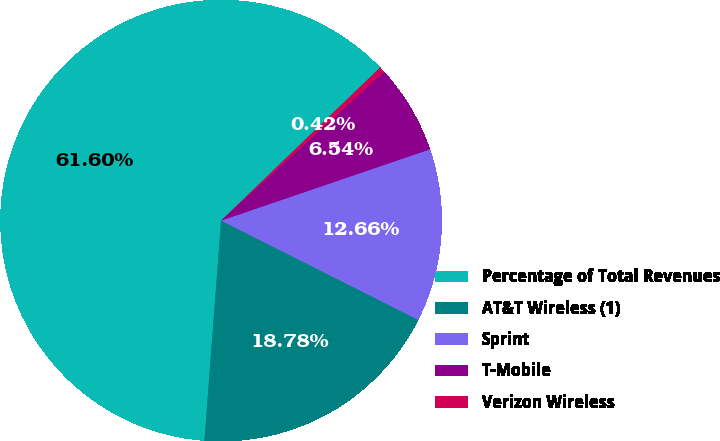<chart> <loc_0><loc_0><loc_500><loc_500><pie_chart><fcel>Percentage of Total Revenues<fcel>AT&T Wireless (1)<fcel>Sprint<fcel>T-Mobile<fcel>Verizon Wireless<nl><fcel>61.6%<fcel>18.78%<fcel>12.66%<fcel>6.54%<fcel>0.42%<nl></chart> 